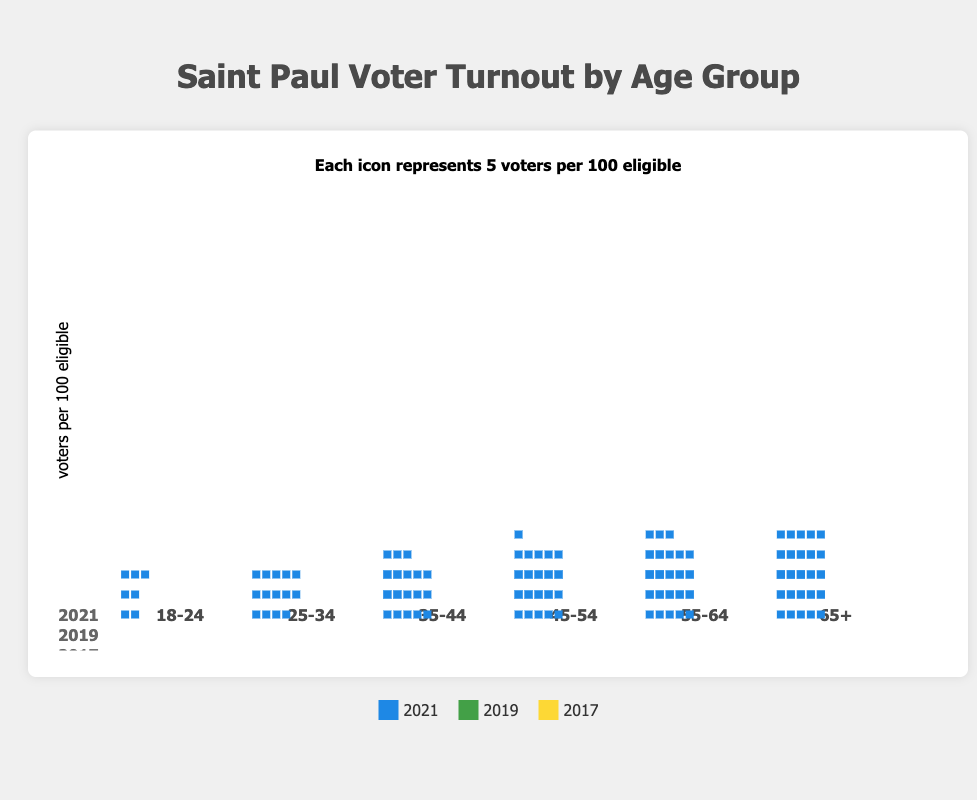What's the title of the figure? The title of the figure is prominently displayed at the top. It reads "Saint Paul Voter Turnout by Age Group".
Answer: Saint Paul Voter Turnout by Age Group What does each icon represent in the plot? The plot includes a label near the top that indicates what each icon stands for. According to the label, each icon represents 5 voters per 100 eligible.
Answer: 5 voters per 100 eligible Which age group had the highest voter turnout in 2021? By examining the icons representing voter turnout for the year 2021 (colored in a specific shade), the age group "65+" has the highest number of icons, indicating the highest voter turnout.
Answer: 65+ How did the voter turnout for the age group 25-34 change from 2017 to 2021? Comparing the icons for the age group 25-34 across the years, in 2017 there were 22%, in 2019 there were 25%, and in 2021 there were 28% voters per 100 eligible. Turnout increased from 22% to 28%.
Answer: Increased by 6% Which year had the lowest voter turnout for the age group 45-54? By checking the number of icons for the age group 45-54 across all years, the lowest number of icons corresponds to the year 2017, indicating the lowest turnout.
Answer: 2017 What is the average voter turnout for the 65+ age group over the years shown? The voter turnout percentages for the 65+ age group are 68% in 2017, 70% in 2019, and 75% in 2021. The average is calculated as (68 + 70 + 75) / 3 = 71%.
Answer: 71% Is the voter turnout for the age group 18-24 increasing or decreasing over the years? Observing the number of icons for the age group 18-24, the turnout increased from 10% in 2017, to 12% in 2019, and to 15% in 2021. The trend shows an increase.
Answer: Increasing Which age group had the smallest increase in voter turnout between 2019 and 2021? By comparing the increase in icons for each age group from 2019 to 2021, the age group 55-64 had an increase from 63% to 68%, which is a 5% difference, the smallest among the recorded increases.
Answer: 55-64 What pattern do you observe about voter turnout as age increases for each given year? For every year depicted (2017, 2019, 2021), the number of icons generally increases with age, showing that voter turnout tends to be higher in older age groups.
Answer: Turnout increases with age 